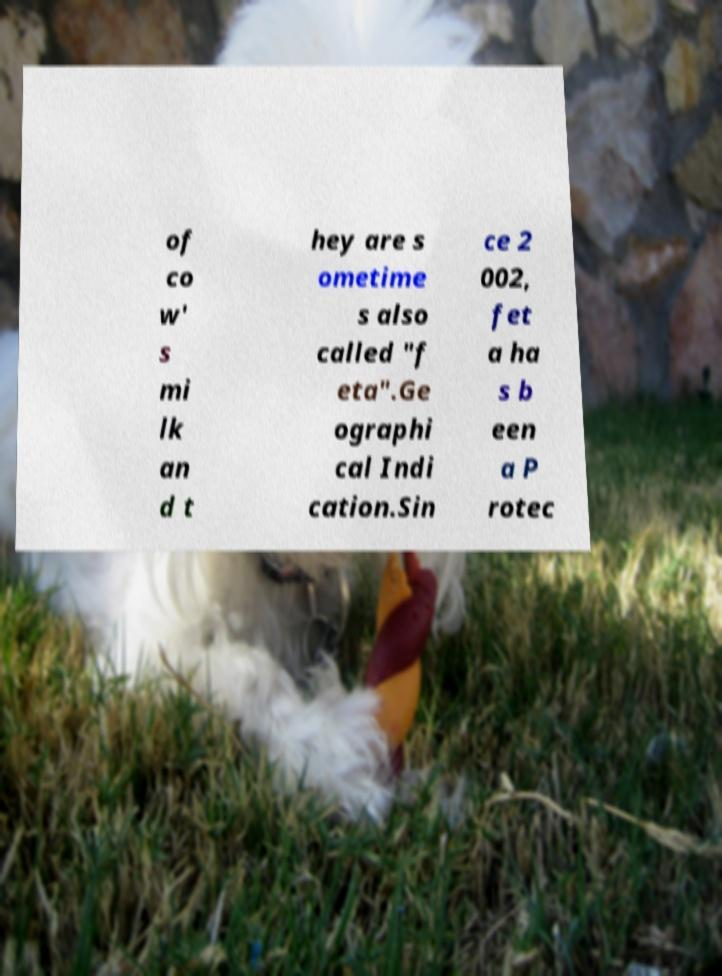There's text embedded in this image that I need extracted. Can you transcribe it verbatim? of co w' s mi lk an d t hey are s ometime s also called "f eta".Ge ographi cal Indi cation.Sin ce 2 002, fet a ha s b een a P rotec 